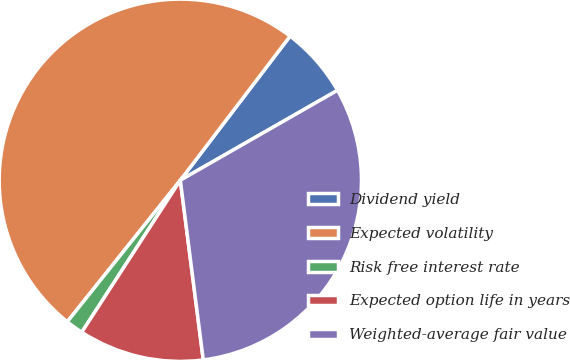<chart> <loc_0><loc_0><loc_500><loc_500><pie_chart><fcel>Dividend yield<fcel>Expected volatility<fcel>Risk free interest rate<fcel>Expected option life in years<fcel>Weighted-average fair value<nl><fcel>6.37%<fcel>49.63%<fcel>1.57%<fcel>11.18%<fcel>31.25%<nl></chart> 